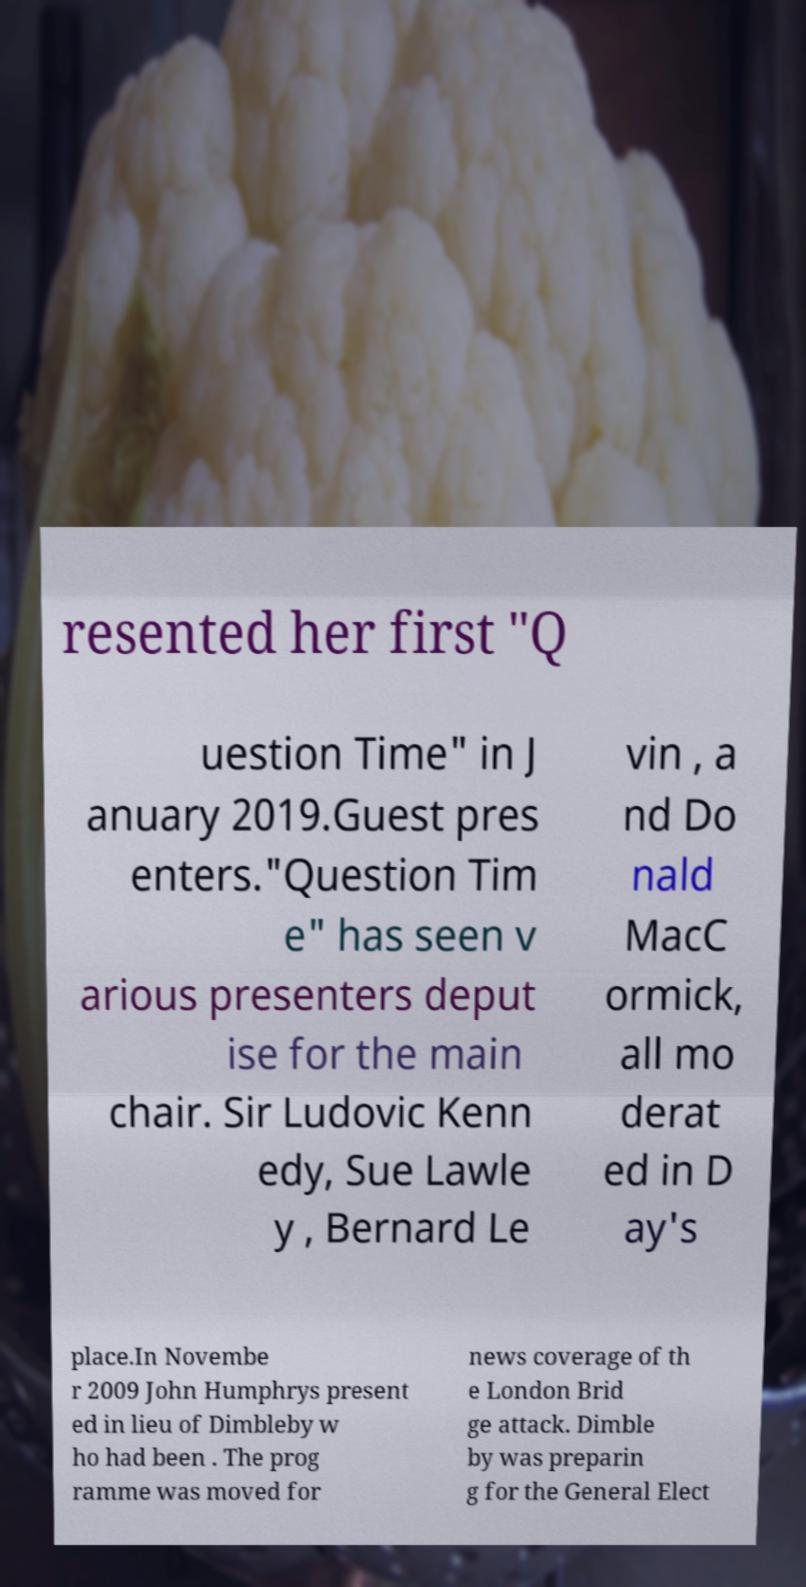Can you read and provide the text displayed in the image?This photo seems to have some interesting text. Can you extract and type it out for me? resented her first "Q uestion Time" in J anuary 2019.Guest pres enters."Question Tim e" has seen v arious presenters deput ise for the main chair. Sir Ludovic Kenn edy, Sue Lawle y , Bernard Le vin , a nd Do nald MacC ormick, all mo derat ed in D ay's place.In Novembe r 2009 John Humphrys present ed in lieu of Dimbleby w ho had been . The prog ramme was moved for news coverage of th e London Brid ge attack. Dimble by was preparin g for the General Elect 